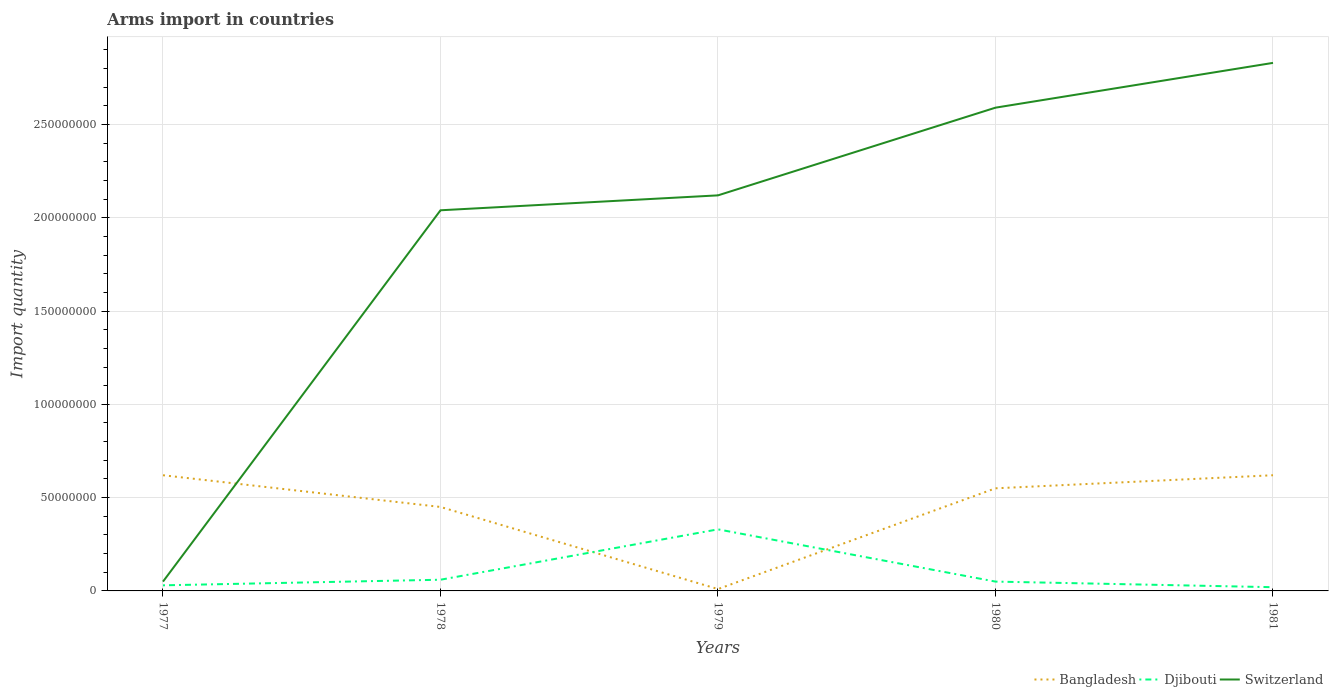Does the line corresponding to Switzerland intersect with the line corresponding to Bangladesh?
Make the answer very short. Yes. Across all years, what is the maximum total arms import in Switzerland?
Provide a succinct answer. 5.00e+06. In which year was the total arms import in Bangladesh maximum?
Your answer should be compact. 1979. What is the total total arms import in Djibouti in the graph?
Keep it short and to the point. 1.00e+06. What is the difference between the highest and the second highest total arms import in Switzerland?
Make the answer very short. 2.78e+08. What is the difference between the highest and the lowest total arms import in Bangladesh?
Provide a succinct answer. 3. Is the total arms import in Bangladesh strictly greater than the total arms import in Djibouti over the years?
Provide a short and direct response. No. How many lines are there?
Offer a terse response. 3. What is the difference between two consecutive major ticks on the Y-axis?
Offer a terse response. 5.00e+07. How are the legend labels stacked?
Ensure brevity in your answer.  Horizontal. What is the title of the graph?
Offer a very short reply. Arms import in countries. What is the label or title of the Y-axis?
Offer a terse response. Import quantity. What is the Import quantity in Bangladesh in 1977?
Offer a terse response. 6.20e+07. What is the Import quantity in Djibouti in 1977?
Give a very brief answer. 3.00e+06. What is the Import quantity in Bangladesh in 1978?
Your answer should be very brief. 4.50e+07. What is the Import quantity in Djibouti in 1978?
Give a very brief answer. 6.00e+06. What is the Import quantity in Switzerland in 1978?
Offer a very short reply. 2.04e+08. What is the Import quantity in Djibouti in 1979?
Keep it short and to the point. 3.30e+07. What is the Import quantity in Switzerland in 1979?
Provide a short and direct response. 2.12e+08. What is the Import quantity of Bangladesh in 1980?
Provide a short and direct response. 5.50e+07. What is the Import quantity in Switzerland in 1980?
Offer a terse response. 2.59e+08. What is the Import quantity in Bangladesh in 1981?
Provide a short and direct response. 6.20e+07. What is the Import quantity in Djibouti in 1981?
Ensure brevity in your answer.  2.00e+06. What is the Import quantity in Switzerland in 1981?
Your answer should be very brief. 2.83e+08. Across all years, what is the maximum Import quantity in Bangladesh?
Keep it short and to the point. 6.20e+07. Across all years, what is the maximum Import quantity in Djibouti?
Give a very brief answer. 3.30e+07. Across all years, what is the maximum Import quantity of Switzerland?
Keep it short and to the point. 2.83e+08. Across all years, what is the minimum Import quantity of Djibouti?
Your answer should be very brief. 2.00e+06. Across all years, what is the minimum Import quantity in Switzerland?
Your answer should be very brief. 5.00e+06. What is the total Import quantity of Bangladesh in the graph?
Provide a short and direct response. 2.25e+08. What is the total Import quantity in Djibouti in the graph?
Offer a terse response. 4.90e+07. What is the total Import quantity of Switzerland in the graph?
Give a very brief answer. 9.63e+08. What is the difference between the Import quantity in Bangladesh in 1977 and that in 1978?
Your answer should be compact. 1.70e+07. What is the difference between the Import quantity of Switzerland in 1977 and that in 1978?
Provide a short and direct response. -1.99e+08. What is the difference between the Import quantity of Bangladesh in 1977 and that in 1979?
Ensure brevity in your answer.  6.10e+07. What is the difference between the Import quantity in Djibouti in 1977 and that in 1979?
Provide a succinct answer. -3.00e+07. What is the difference between the Import quantity of Switzerland in 1977 and that in 1979?
Provide a short and direct response. -2.07e+08. What is the difference between the Import quantity in Switzerland in 1977 and that in 1980?
Your answer should be very brief. -2.54e+08. What is the difference between the Import quantity of Bangladesh in 1977 and that in 1981?
Provide a short and direct response. 0. What is the difference between the Import quantity in Djibouti in 1977 and that in 1981?
Ensure brevity in your answer.  1.00e+06. What is the difference between the Import quantity in Switzerland in 1977 and that in 1981?
Offer a terse response. -2.78e+08. What is the difference between the Import quantity of Bangladesh in 1978 and that in 1979?
Your answer should be compact. 4.40e+07. What is the difference between the Import quantity of Djibouti in 1978 and that in 1979?
Give a very brief answer. -2.70e+07. What is the difference between the Import quantity of Switzerland in 1978 and that in 1979?
Ensure brevity in your answer.  -8.00e+06. What is the difference between the Import quantity of Bangladesh in 1978 and that in 1980?
Ensure brevity in your answer.  -1.00e+07. What is the difference between the Import quantity in Djibouti in 1978 and that in 1980?
Keep it short and to the point. 1.00e+06. What is the difference between the Import quantity of Switzerland in 1978 and that in 1980?
Provide a succinct answer. -5.50e+07. What is the difference between the Import quantity of Bangladesh in 1978 and that in 1981?
Offer a very short reply. -1.70e+07. What is the difference between the Import quantity of Switzerland in 1978 and that in 1981?
Provide a succinct answer. -7.90e+07. What is the difference between the Import quantity of Bangladesh in 1979 and that in 1980?
Your answer should be very brief. -5.40e+07. What is the difference between the Import quantity of Djibouti in 1979 and that in 1980?
Your answer should be compact. 2.80e+07. What is the difference between the Import quantity of Switzerland in 1979 and that in 1980?
Offer a very short reply. -4.70e+07. What is the difference between the Import quantity of Bangladesh in 1979 and that in 1981?
Give a very brief answer. -6.10e+07. What is the difference between the Import quantity of Djibouti in 1979 and that in 1981?
Give a very brief answer. 3.10e+07. What is the difference between the Import quantity in Switzerland in 1979 and that in 1981?
Offer a terse response. -7.10e+07. What is the difference between the Import quantity of Bangladesh in 1980 and that in 1981?
Offer a very short reply. -7.00e+06. What is the difference between the Import quantity of Djibouti in 1980 and that in 1981?
Provide a succinct answer. 3.00e+06. What is the difference between the Import quantity of Switzerland in 1980 and that in 1981?
Provide a succinct answer. -2.40e+07. What is the difference between the Import quantity in Bangladesh in 1977 and the Import quantity in Djibouti in 1978?
Provide a short and direct response. 5.60e+07. What is the difference between the Import quantity in Bangladesh in 1977 and the Import quantity in Switzerland in 1978?
Keep it short and to the point. -1.42e+08. What is the difference between the Import quantity of Djibouti in 1977 and the Import quantity of Switzerland in 1978?
Keep it short and to the point. -2.01e+08. What is the difference between the Import quantity in Bangladesh in 1977 and the Import quantity in Djibouti in 1979?
Ensure brevity in your answer.  2.90e+07. What is the difference between the Import quantity in Bangladesh in 1977 and the Import quantity in Switzerland in 1979?
Give a very brief answer. -1.50e+08. What is the difference between the Import quantity in Djibouti in 1977 and the Import quantity in Switzerland in 1979?
Your response must be concise. -2.09e+08. What is the difference between the Import quantity of Bangladesh in 1977 and the Import quantity of Djibouti in 1980?
Provide a succinct answer. 5.70e+07. What is the difference between the Import quantity in Bangladesh in 1977 and the Import quantity in Switzerland in 1980?
Your answer should be very brief. -1.97e+08. What is the difference between the Import quantity in Djibouti in 1977 and the Import quantity in Switzerland in 1980?
Keep it short and to the point. -2.56e+08. What is the difference between the Import quantity of Bangladesh in 1977 and the Import quantity of Djibouti in 1981?
Your answer should be compact. 6.00e+07. What is the difference between the Import quantity of Bangladesh in 1977 and the Import quantity of Switzerland in 1981?
Provide a succinct answer. -2.21e+08. What is the difference between the Import quantity in Djibouti in 1977 and the Import quantity in Switzerland in 1981?
Ensure brevity in your answer.  -2.80e+08. What is the difference between the Import quantity in Bangladesh in 1978 and the Import quantity in Switzerland in 1979?
Make the answer very short. -1.67e+08. What is the difference between the Import quantity of Djibouti in 1978 and the Import quantity of Switzerland in 1979?
Your answer should be very brief. -2.06e+08. What is the difference between the Import quantity in Bangladesh in 1978 and the Import quantity in Djibouti in 1980?
Your answer should be compact. 4.00e+07. What is the difference between the Import quantity in Bangladesh in 1978 and the Import quantity in Switzerland in 1980?
Provide a short and direct response. -2.14e+08. What is the difference between the Import quantity of Djibouti in 1978 and the Import quantity of Switzerland in 1980?
Keep it short and to the point. -2.53e+08. What is the difference between the Import quantity of Bangladesh in 1978 and the Import quantity of Djibouti in 1981?
Your answer should be very brief. 4.30e+07. What is the difference between the Import quantity in Bangladesh in 1978 and the Import quantity in Switzerland in 1981?
Provide a succinct answer. -2.38e+08. What is the difference between the Import quantity of Djibouti in 1978 and the Import quantity of Switzerland in 1981?
Offer a terse response. -2.77e+08. What is the difference between the Import quantity of Bangladesh in 1979 and the Import quantity of Switzerland in 1980?
Make the answer very short. -2.58e+08. What is the difference between the Import quantity in Djibouti in 1979 and the Import quantity in Switzerland in 1980?
Your answer should be compact. -2.26e+08. What is the difference between the Import quantity of Bangladesh in 1979 and the Import quantity of Switzerland in 1981?
Keep it short and to the point. -2.82e+08. What is the difference between the Import quantity of Djibouti in 1979 and the Import quantity of Switzerland in 1981?
Offer a very short reply. -2.50e+08. What is the difference between the Import quantity of Bangladesh in 1980 and the Import quantity of Djibouti in 1981?
Keep it short and to the point. 5.30e+07. What is the difference between the Import quantity in Bangladesh in 1980 and the Import quantity in Switzerland in 1981?
Make the answer very short. -2.28e+08. What is the difference between the Import quantity in Djibouti in 1980 and the Import quantity in Switzerland in 1981?
Offer a very short reply. -2.78e+08. What is the average Import quantity of Bangladesh per year?
Offer a terse response. 4.50e+07. What is the average Import quantity of Djibouti per year?
Give a very brief answer. 9.80e+06. What is the average Import quantity of Switzerland per year?
Ensure brevity in your answer.  1.93e+08. In the year 1977, what is the difference between the Import quantity in Bangladesh and Import quantity in Djibouti?
Your response must be concise. 5.90e+07. In the year 1977, what is the difference between the Import quantity in Bangladesh and Import quantity in Switzerland?
Make the answer very short. 5.70e+07. In the year 1977, what is the difference between the Import quantity in Djibouti and Import quantity in Switzerland?
Make the answer very short. -2.00e+06. In the year 1978, what is the difference between the Import quantity in Bangladesh and Import quantity in Djibouti?
Provide a short and direct response. 3.90e+07. In the year 1978, what is the difference between the Import quantity of Bangladesh and Import quantity of Switzerland?
Provide a short and direct response. -1.59e+08. In the year 1978, what is the difference between the Import quantity in Djibouti and Import quantity in Switzerland?
Your answer should be compact. -1.98e+08. In the year 1979, what is the difference between the Import quantity of Bangladesh and Import quantity of Djibouti?
Keep it short and to the point. -3.20e+07. In the year 1979, what is the difference between the Import quantity of Bangladesh and Import quantity of Switzerland?
Ensure brevity in your answer.  -2.11e+08. In the year 1979, what is the difference between the Import quantity of Djibouti and Import quantity of Switzerland?
Offer a terse response. -1.79e+08. In the year 1980, what is the difference between the Import quantity in Bangladesh and Import quantity in Djibouti?
Provide a succinct answer. 5.00e+07. In the year 1980, what is the difference between the Import quantity of Bangladesh and Import quantity of Switzerland?
Offer a very short reply. -2.04e+08. In the year 1980, what is the difference between the Import quantity in Djibouti and Import quantity in Switzerland?
Ensure brevity in your answer.  -2.54e+08. In the year 1981, what is the difference between the Import quantity of Bangladesh and Import quantity of Djibouti?
Your answer should be compact. 6.00e+07. In the year 1981, what is the difference between the Import quantity of Bangladesh and Import quantity of Switzerland?
Make the answer very short. -2.21e+08. In the year 1981, what is the difference between the Import quantity of Djibouti and Import quantity of Switzerland?
Make the answer very short. -2.81e+08. What is the ratio of the Import quantity of Bangladesh in 1977 to that in 1978?
Offer a terse response. 1.38. What is the ratio of the Import quantity in Switzerland in 1977 to that in 1978?
Provide a short and direct response. 0.02. What is the ratio of the Import quantity in Djibouti in 1977 to that in 1979?
Provide a short and direct response. 0.09. What is the ratio of the Import quantity in Switzerland in 1977 to that in 1979?
Keep it short and to the point. 0.02. What is the ratio of the Import quantity in Bangladesh in 1977 to that in 1980?
Your answer should be very brief. 1.13. What is the ratio of the Import quantity in Djibouti in 1977 to that in 1980?
Ensure brevity in your answer.  0.6. What is the ratio of the Import quantity of Switzerland in 1977 to that in 1980?
Your answer should be compact. 0.02. What is the ratio of the Import quantity in Bangladesh in 1977 to that in 1981?
Provide a short and direct response. 1. What is the ratio of the Import quantity in Switzerland in 1977 to that in 1981?
Provide a short and direct response. 0.02. What is the ratio of the Import quantity of Bangladesh in 1978 to that in 1979?
Keep it short and to the point. 45. What is the ratio of the Import quantity in Djibouti in 1978 to that in 1979?
Make the answer very short. 0.18. What is the ratio of the Import quantity in Switzerland in 1978 to that in 1979?
Provide a succinct answer. 0.96. What is the ratio of the Import quantity in Bangladesh in 1978 to that in 1980?
Offer a very short reply. 0.82. What is the ratio of the Import quantity in Switzerland in 1978 to that in 1980?
Give a very brief answer. 0.79. What is the ratio of the Import quantity of Bangladesh in 1978 to that in 1981?
Offer a very short reply. 0.73. What is the ratio of the Import quantity of Djibouti in 1978 to that in 1981?
Your answer should be very brief. 3. What is the ratio of the Import quantity of Switzerland in 1978 to that in 1981?
Make the answer very short. 0.72. What is the ratio of the Import quantity of Bangladesh in 1979 to that in 1980?
Provide a short and direct response. 0.02. What is the ratio of the Import quantity of Switzerland in 1979 to that in 1980?
Provide a short and direct response. 0.82. What is the ratio of the Import quantity in Bangladesh in 1979 to that in 1981?
Your response must be concise. 0.02. What is the ratio of the Import quantity in Djibouti in 1979 to that in 1981?
Your response must be concise. 16.5. What is the ratio of the Import quantity of Switzerland in 1979 to that in 1981?
Offer a terse response. 0.75. What is the ratio of the Import quantity of Bangladesh in 1980 to that in 1981?
Ensure brevity in your answer.  0.89. What is the ratio of the Import quantity in Djibouti in 1980 to that in 1981?
Your answer should be compact. 2.5. What is the ratio of the Import quantity of Switzerland in 1980 to that in 1981?
Provide a short and direct response. 0.92. What is the difference between the highest and the second highest Import quantity of Djibouti?
Your answer should be compact. 2.70e+07. What is the difference between the highest and the second highest Import quantity in Switzerland?
Your answer should be very brief. 2.40e+07. What is the difference between the highest and the lowest Import quantity of Bangladesh?
Give a very brief answer. 6.10e+07. What is the difference between the highest and the lowest Import quantity in Djibouti?
Make the answer very short. 3.10e+07. What is the difference between the highest and the lowest Import quantity of Switzerland?
Your answer should be compact. 2.78e+08. 